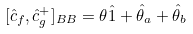<formula> <loc_0><loc_0><loc_500><loc_500>[ \hat { c } _ { f } , \hat { c } _ { g } ^ { + } ] _ { B B } = \theta \hat { 1 } + \hat { \theta } _ { a } + \hat { \theta } _ { b }</formula> 